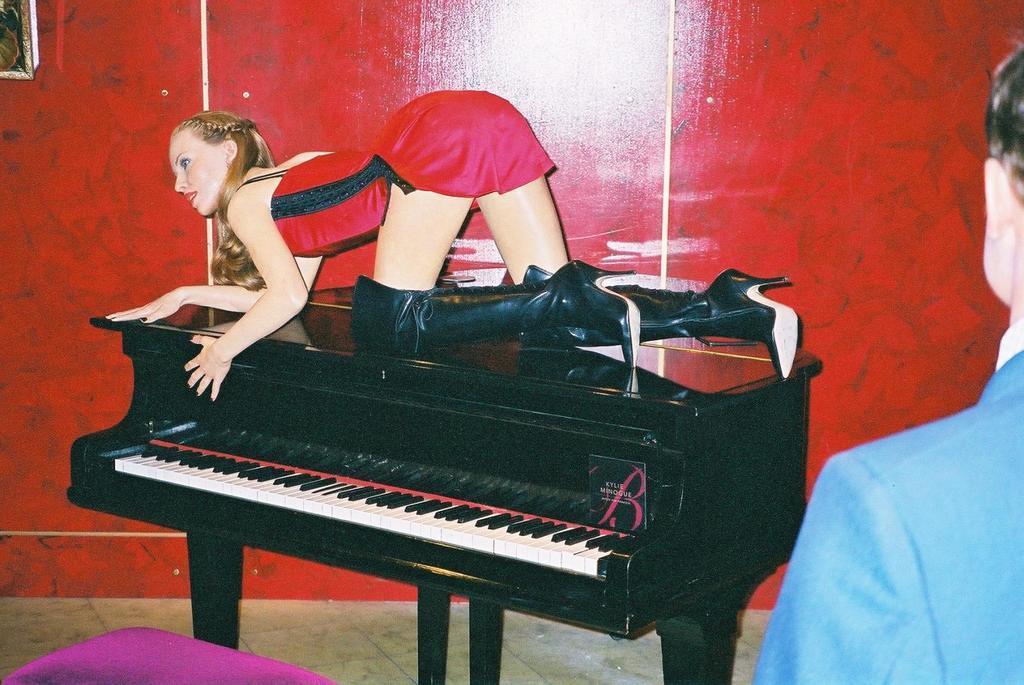Can you describe this image briefly? Above the piano there is a person. On the background we can see wall. This is floor. 